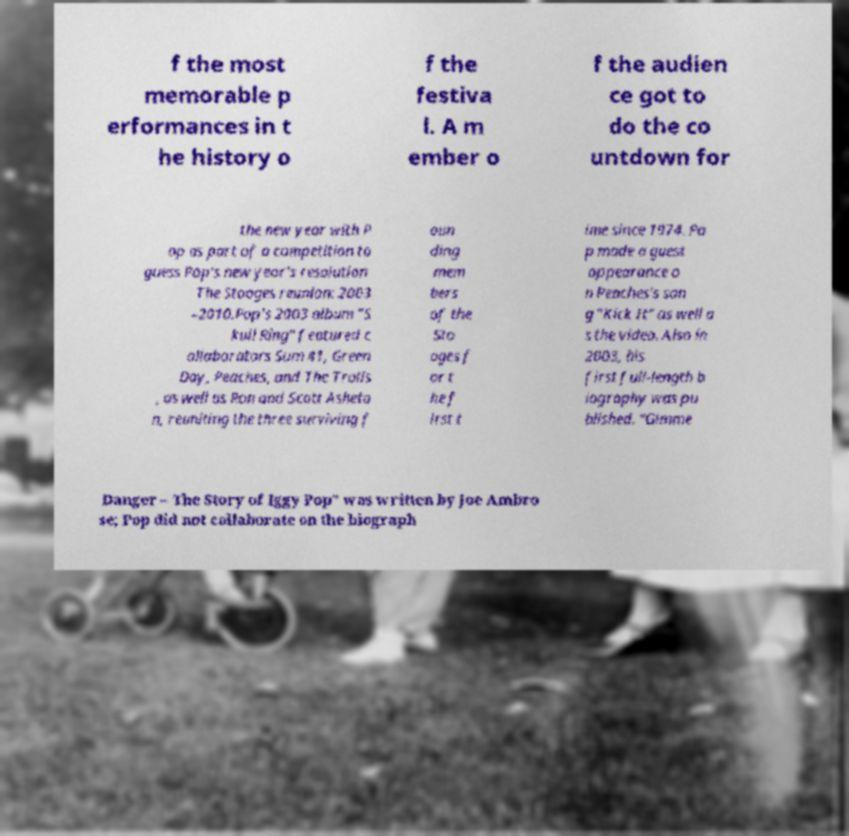Please identify and transcribe the text found in this image. f the most memorable p erformances in t he history o f the festiva l. A m ember o f the audien ce got to do the co untdown for the new year with P op as part of a competition to guess Pop's new year's resolution The Stooges reunion: 2003 –2010.Pop's 2003 album "S kull Ring" featured c ollaborators Sum 41, Green Day, Peaches, and The Trolls , as well as Ron and Scott Asheto n, reuniting the three surviving f oun ding mem bers of the Sto oges f or t he f irst t ime since 1974. Po p made a guest appearance o n Peaches's son g "Kick It" as well a s the video. Also in 2003, his first full-length b iography was pu blished. "Gimme Danger – The Story of Iggy Pop" was written by Joe Ambro se; Pop did not collaborate on the biograph 